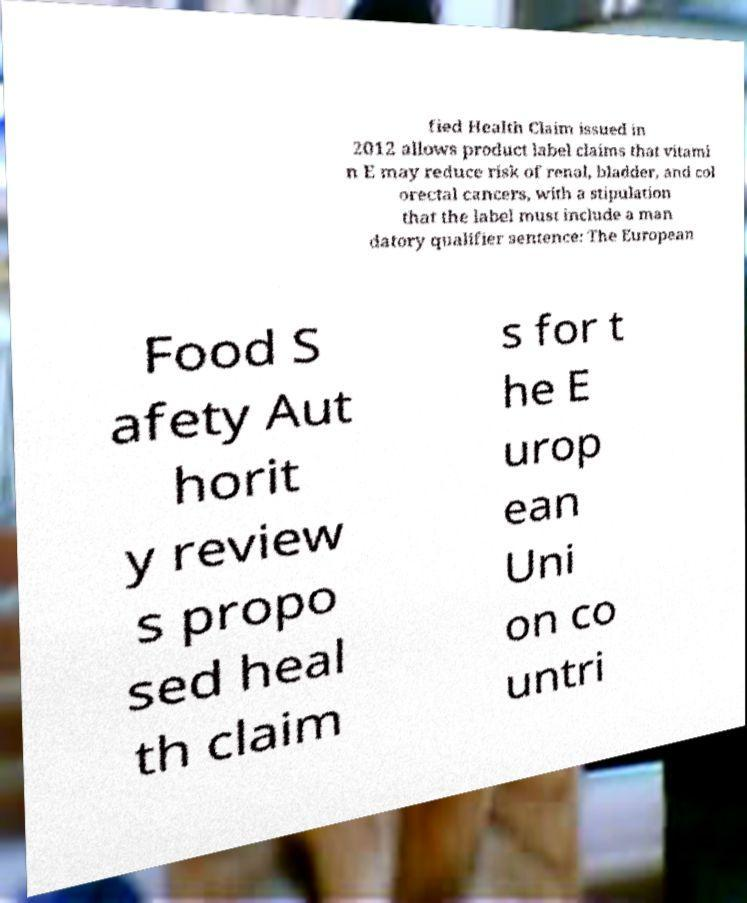I need the written content from this picture converted into text. Can you do that? fied Health Claim issued in 2012 allows product label claims that vitami n E may reduce risk of renal, bladder, and col orectal cancers, with a stipulation that the label must include a man datory qualifier sentence: The European Food S afety Aut horit y review s propo sed heal th claim s for t he E urop ean Uni on co untri 